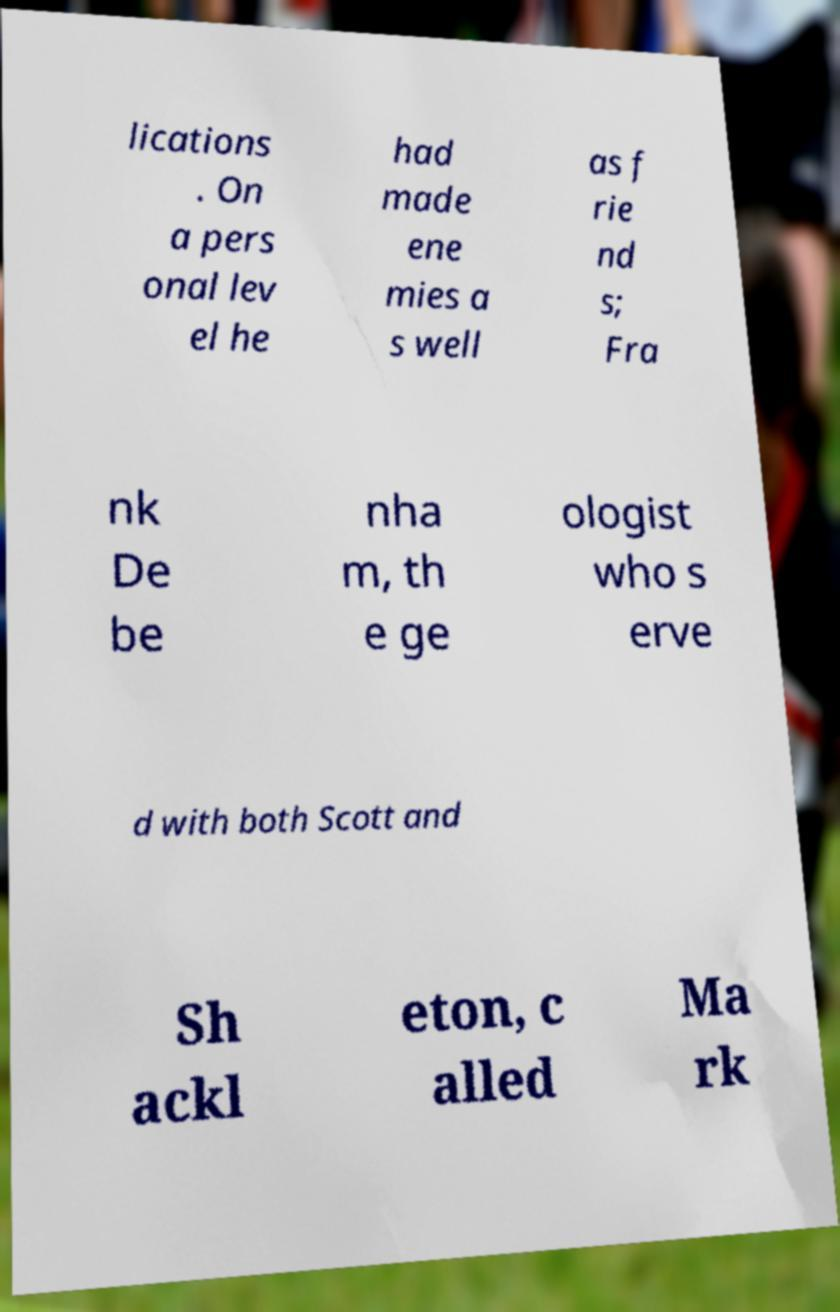I need the written content from this picture converted into text. Can you do that? lications . On a pers onal lev el he had made ene mies a s well as f rie nd s; Fra nk De be nha m, th e ge ologist who s erve d with both Scott and Sh ackl eton, c alled Ma rk 